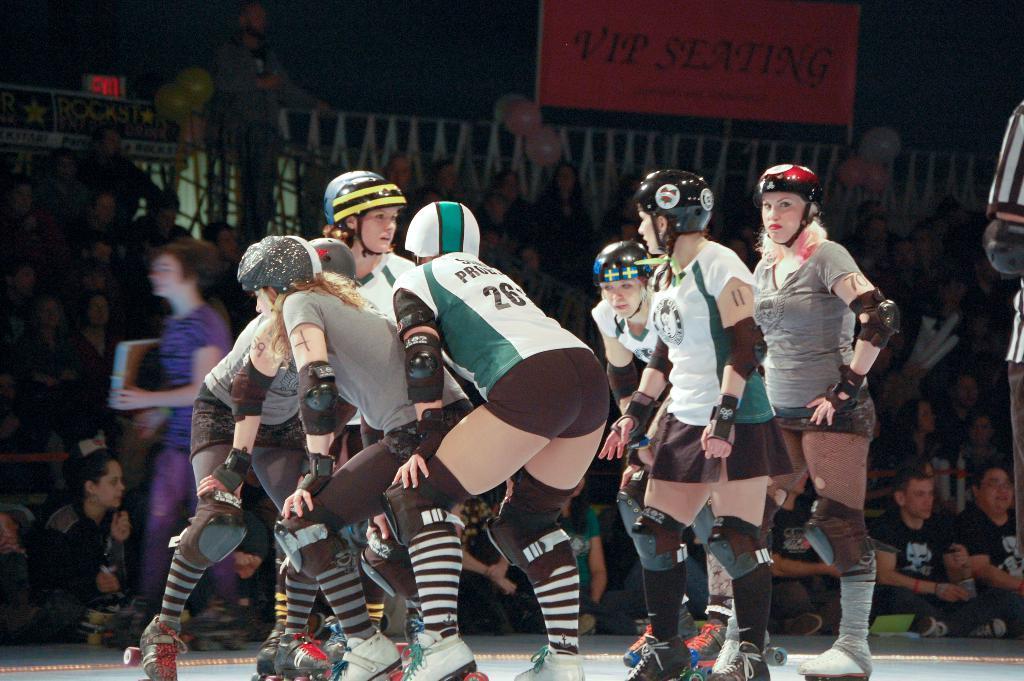Can you describe this image briefly? In this image I can see few persons wearing sports dress and skating shoes. And in the background there are some people who are sitting and a person of violet dress is walking. Also at top of the image there is a banner with some text written on it. 